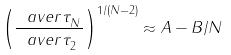<formula> <loc_0><loc_0><loc_500><loc_500>\left ( \frac { \ a v e r { \tau ^ { \ } _ { N } } } { \ a v e r { \tau ^ { \ } _ { 2 } } } \right ) ^ { 1 / ( N - 2 ) } \approx A - B / N</formula> 